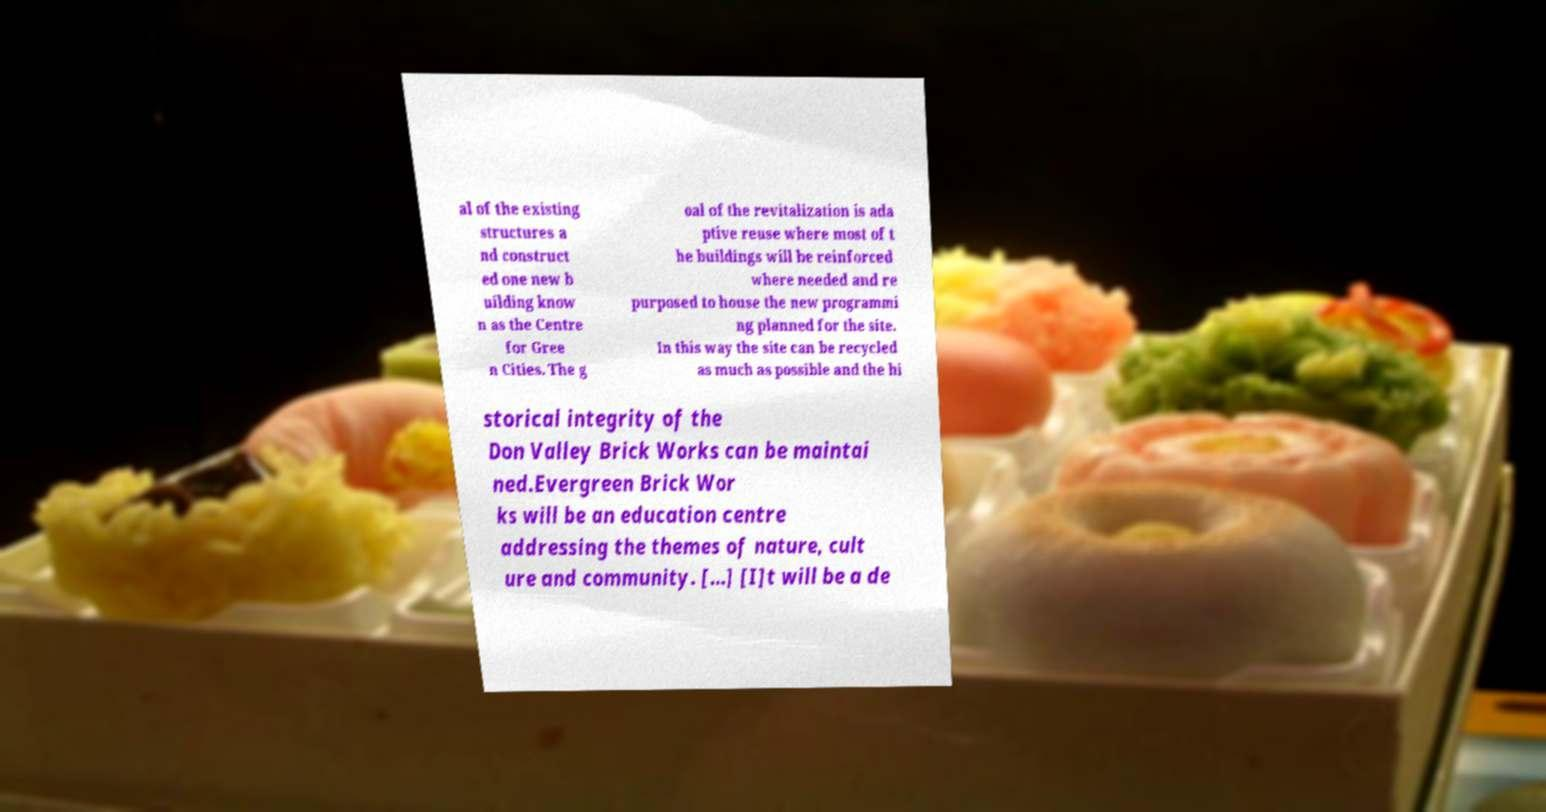For documentation purposes, I need the text within this image transcribed. Could you provide that? al of the existing structures a nd construct ed one new b uilding know n as the Centre for Gree n Cities. The g oal of the revitalization is ada ptive reuse where most of t he buildings will be reinforced where needed and re purposed to house the new programmi ng planned for the site. In this way the site can be recycled as much as possible and the hi storical integrity of the Don Valley Brick Works can be maintai ned.Evergreen Brick Wor ks will be an education centre addressing the themes of nature, cult ure and community. [...] [I]t will be a de 